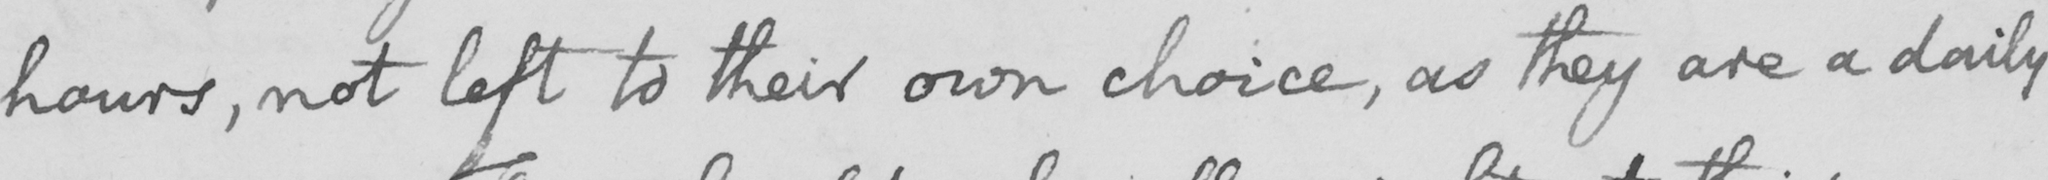Please transcribe the handwritten text in this image. hours , not left to their own choice , as they are a daily 